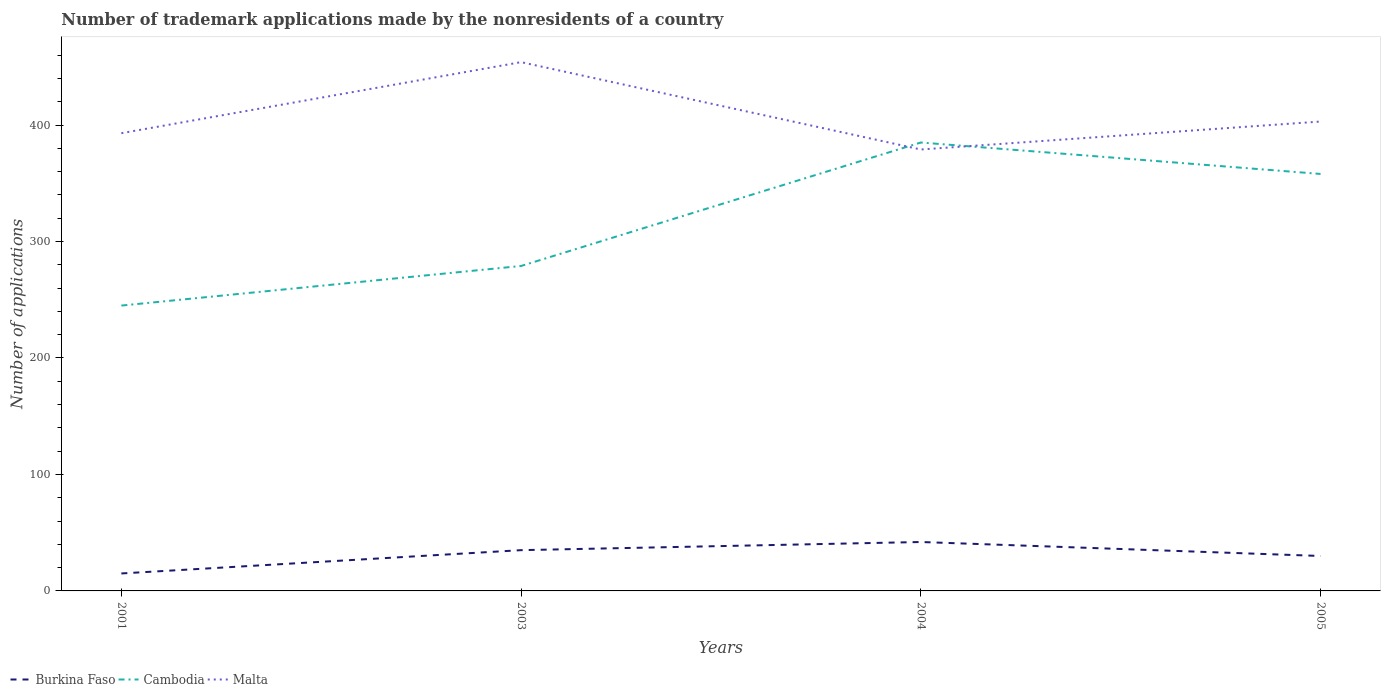How many different coloured lines are there?
Make the answer very short. 3. Does the line corresponding to Malta intersect with the line corresponding to Burkina Faso?
Ensure brevity in your answer.  No. Across all years, what is the maximum number of trademark applications made by the nonresidents in Malta?
Your response must be concise. 379. In which year was the number of trademark applications made by the nonresidents in Malta maximum?
Ensure brevity in your answer.  2004. What is the total number of trademark applications made by the nonresidents in Burkina Faso in the graph?
Ensure brevity in your answer.  -15. What is the difference between the highest and the second highest number of trademark applications made by the nonresidents in Burkina Faso?
Your answer should be compact. 27. Is the number of trademark applications made by the nonresidents in Malta strictly greater than the number of trademark applications made by the nonresidents in Cambodia over the years?
Ensure brevity in your answer.  No. How many years are there in the graph?
Make the answer very short. 4. What is the difference between two consecutive major ticks on the Y-axis?
Give a very brief answer. 100. Are the values on the major ticks of Y-axis written in scientific E-notation?
Provide a short and direct response. No. Does the graph contain any zero values?
Make the answer very short. No. Does the graph contain grids?
Offer a very short reply. No. How many legend labels are there?
Give a very brief answer. 3. What is the title of the graph?
Offer a very short reply. Number of trademark applications made by the nonresidents of a country. What is the label or title of the X-axis?
Offer a terse response. Years. What is the label or title of the Y-axis?
Give a very brief answer. Number of applications. What is the Number of applications of Burkina Faso in 2001?
Provide a succinct answer. 15. What is the Number of applications in Cambodia in 2001?
Your response must be concise. 245. What is the Number of applications in Malta in 2001?
Provide a short and direct response. 393. What is the Number of applications in Burkina Faso in 2003?
Make the answer very short. 35. What is the Number of applications of Cambodia in 2003?
Your answer should be very brief. 279. What is the Number of applications in Malta in 2003?
Your answer should be compact. 454. What is the Number of applications in Burkina Faso in 2004?
Offer a terse response. 42. What is the Number of applications in Cambodia in 2004?
Your answer should be compact. 385. What is the Number of applications of Malta in 2004?
Keep it short and to the point. 379. What is the Number of applications of Cambodia in 2005?
Give a very brief answer. 358. What is the Number of applications in Malta in 2005?
Offer a terse response. 403. Across all years, what is the maximum Number of applications in Burkina Faso?
Make the answer very short. 42. Across all years, what is the maximum Number of applications of Cambodia?
Ensure brevity in your answer.  385. Across all years, what is the maximum Number of applications in Malta?
Provide a short and direct response. 454. Across all years, what is the minimum Number of applications of Cambodia?
Provide a short and direct response. 245. Across all years, what is the minimum Number of applications in Malta?
Offer a terse response. 379. What is the total Number of applications of Burkina Faso in the graph?
Your response must be concise. 122. What is the total Number of applications in Cambodia in the graph?
Offer a terse response. 1267. What is the total Number of applications in Malta in the graph?
Provide a succinct answer. 1629. What is the difference between the Number of applications in Cambodia in 2001 and that in 2003?
Provide a succinct answer. -34. What is the difference between the Number of applications of Malta in 2001 and that in 2003?
Make the answer very short. -61. What is the difference between the Number of applications in Cambodia in 2001 and that in 2004?
Offer a very short reply. -140. What is the difference between the Number of applications in Malta in 2001 and that in 2004?
Make the answer very short. 14. What is the difference between the Number of applications of Burkina Faso in 2001 and that in 2005?
Offer a terse response. -15. What is the difference between the Number of applications of Cambodia in 2001 and that in 2005?
Ensure brevity in your answer.  -113. What is the difference between the Number of applications in Malta in 2001 and that in 2005?
Your answer should be very brief. -10. What is the difference between the Number of applications in Cambodia in 2003 and that in 2004?
Your answer should be compact. -106. What is the difference between the Number of applications of Malta in 2003 and that in 2004?
Give a very brief answer. 75. What is the difference between the Number of applications of Burkina Faso in 2003 and that in 2005?
Offer a very short reply. 5. What is the difference between the Number of applications of Cambodia in 2003 and that in 2005?
Ensure brevity in your answer.  -79. What is the difference between the Number of applications of Burkina Faso in 2004 and that in 2005?
Keep it short and to the point. 12. What is the difference between the Number of applications in Malta in 2004 and that in 2005?
Your answer should be compact. -24. What is the difference between the Number of applications of Burkina Faso in 2001 and the Number of applications of Cambodia in 2003?
Offer a terse response. -264. What is the difference between the Number of applications of Burkina Faso in 2001 and the Number of applications of Malta in 2003?
Provide a short and direct response. -439. What is the difference between the Number of applications of Cambodia in 2001 and the Number of applications of Malta in 2003?
Your response must be concise. -209. What is the difference between the Number of applications of Burkina Faso in 2001 and the Number of applications of Cambodia in 2004?
Provide a succinct answer. -370. What is the difference between the Number of applications in Burkina Faso in 2001 and the Number of applications in Malta in 2004?
Offer a terse response. -364. What is the difference between the Number of applications of Cambodia in 2001 and the Number of applications of Malta in 2004?
Keep it short and to the point. -134. What is the difference between the Number of applications of Burkina Faso in 2001 and the Number of applications of Cambodia in 2005?
Keep it short and to the point. -343. What is the difference between the Number of applications of Burkina Faso in 2001 and the Number of applications of Malta in 2005?
Offer a very short reply. -388. What is the difference between the Number of applications in Cambodia in 2001 and the Number of applications in Malta in 2005?
Ensure brevity in your answer.  -158. What is the difference between the Number of applications in Burkina Faso in 2003 and the Number of applications in Cambodia in 2004?
Your answer should be compact. -350. What is the difference between the Number of applications in Burkina Faso in 2003 and the Number of applications in Malta in 2004?
Your answer should be very brief. -344. What is the difference between the Number of applications in Cambodia in 2003 and the Number of applications in Malta in 2004?
Make the answer very short. -100. What is the difference between the Number of applications in Burkina Faso in 2003 and the Number of applications in Cambodia in 2005?
Offer a terse response. -323. What is the difference between the Number of applications of Burkina Faso in 2003 and the Number of applications of Malta in 2005?
Offer a terse response. -368. What is the difference between the Number of applications in Cambodia in 2003 and the Number of applications in Malta in 2005?
Provide a short and direct response. -124. What is the difference between the Number of applications in Burkina Faso in 2004 and the Number of applications in Cambodia in 2005?
Provide a succinct answer. -316. What is the difference between the Number of applications of Burkina Faso in 2004 and the Number of applications of Malta in 2005?
Your answer should be compact. -361. What is the difference between the Number of applications of Cambodia in 2004 and the Number of applications of Malta in 2005?
Your answer should be compact. -18. What is the average Number of applications of Burkina Faso per year?
Your answer should be compact. 30.5. What is the average Number of applications in Cambodia per year?
Give a very brief answer. 316.75. What is the average Number of applications of Malta per year?
Provide a short and direct response. 407.25. In the year 2001, what is the difference between the Number of applications in Burkina Faso and Number of applications in Cambodia?
Offer a terse response. -230. In the year 2001, what is the difference between the Number of applications of Burkina Faso and Number of applications of Malta?
Provide a short and direct response. -378. In the year 2001, what is the difference between the Number of applications in Cambodia and Number of applications in Malta?
Your answer should be very brief. -148. In the year 2003, what is the difference between the Number of applications of Burkina Faso and Number of applications of Cambodia?
Your response must be concise. -244. In the year 2003, what is the difference between the Number of applications of Burkina Faso and Number of applications of Malta?
Your answer should be very brief. -419. In the year 2003, what is the difference between the Number of applications in Cambodia and Number of applications in Malta?
Make the answer very short. -175. In the year 2004, what is the difference between the Number of applications in Burkina Faso and Number of applications in Cambodia?
Keep it short and to the point. -343. In the year 2004, what is the difference between the Number of applications in Burkina Faso and Number of applications in Malta?
Offer a very short reply. -337. In the year 2005, what is the difference between the Number of applications in Burkina Faso and Number of applications in Cambodia?
Ensure brevity in your answer.  -328. In the year 2005, what is the difference between the Number of applications in Burkina Faso and Number of applications in Malta?
Give a very brief answer. -373. In the year 2005, what is the difference between the Number of applications in Cambodia and Number of applications in Malta?
Make the answer very short. -45. What is the ratio of the Number of applications in Burkina Faso in 2001 to that in 2003?
Your answer should be very brief. 0.43. What is the ratio of the Number of applications in Cambodia in 2001 to that in 2003?
Give a very brief answer. 0.88. What is the ratio of the Number of applications of Malta in 2001 to that in 2003?
Provide a short and direct response. 0.87. What is the ratio of the Number of applications in Burkina Faso in 2001 to that in 2004?
Provide a short and direct response. 0.36. What is the ratio of the Number of applications in Cambodia in 2001 to that in 2004?
Keep it short and to the point. 0.64. What is the ratio of the Number of applications of Malta in 2001 to that in 2004?
Make the answer very short. 1.04. What is the ratio of the Number of applications of Burkina Faso in 2001 to that in 2005?
Your response must be concise. 0.5. What is the ratio of the Number of applications in Cambodia in 2001 to that in 2005?
Keep it short and to the point. 0.68. What is the ratio of the Number of applications of Malta in 2001 to that in 2005?
Keep it short and to the point. 0.98. What is the ratio of the Number of applications in Burkina Faso in 2003 to that in 2004?
Provide a succinct answer. 0.83. What is the ratio of the Number of applications of Cambodia in 2003 to that in 2004?
Give a very brief answer. 0.72. What is the ratio of the Number of applications in Malta in 2003 to that in 2004?
Provide a short and direct response. 1.2. What is the ratio of the Number of applications in Cambodia in 2003 to that in 2005?
Give a very brief answer. 0.78. What is the ratio of the Number of applications in Malta in 2003 to that in 2005?
Offer a terse response. 1.13. What is the ratio of the Number of applications of Burkina Faso in 2004 to that in 2005?
Offer a terse response. 1.4. What is the ratio of the Number of applications of Cambodia in 2004 to that in 2005?
Make the answer very short. 1.08. What is the ratio of the Number of applications in Malta in 2004 to that in 2005?
Your answer should be very brief. 0.94. What is the difference between the highest and the second highest Number of applications of Burkina Faso?
Make the answer very short. 7. What is the difference between the highest and the lowest Number of applications in Burkina Faso?
Ensure brevity in your answer.  27. What is the difference between the highest and the lowest Number of applications in Cambodia?
Provide a succinct answer. 140. 